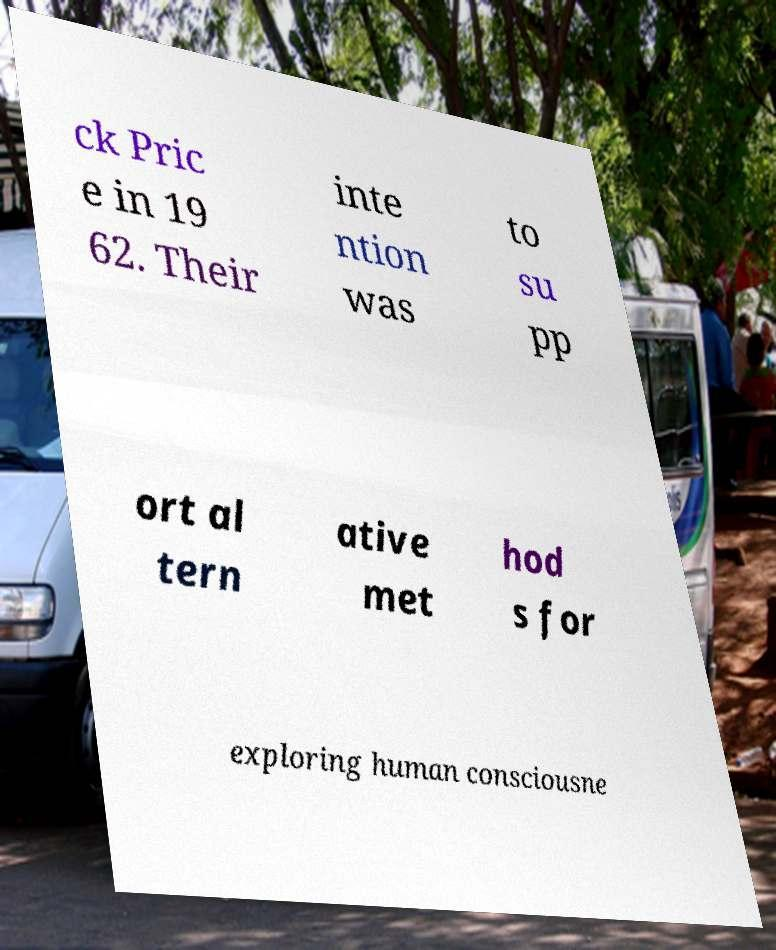Can you accurately transcribe the text from the provided image for me? ck Pric e in 19 62. Their inte ntion was to su pp ort al tern ative met hod s for exploring human consciousne 